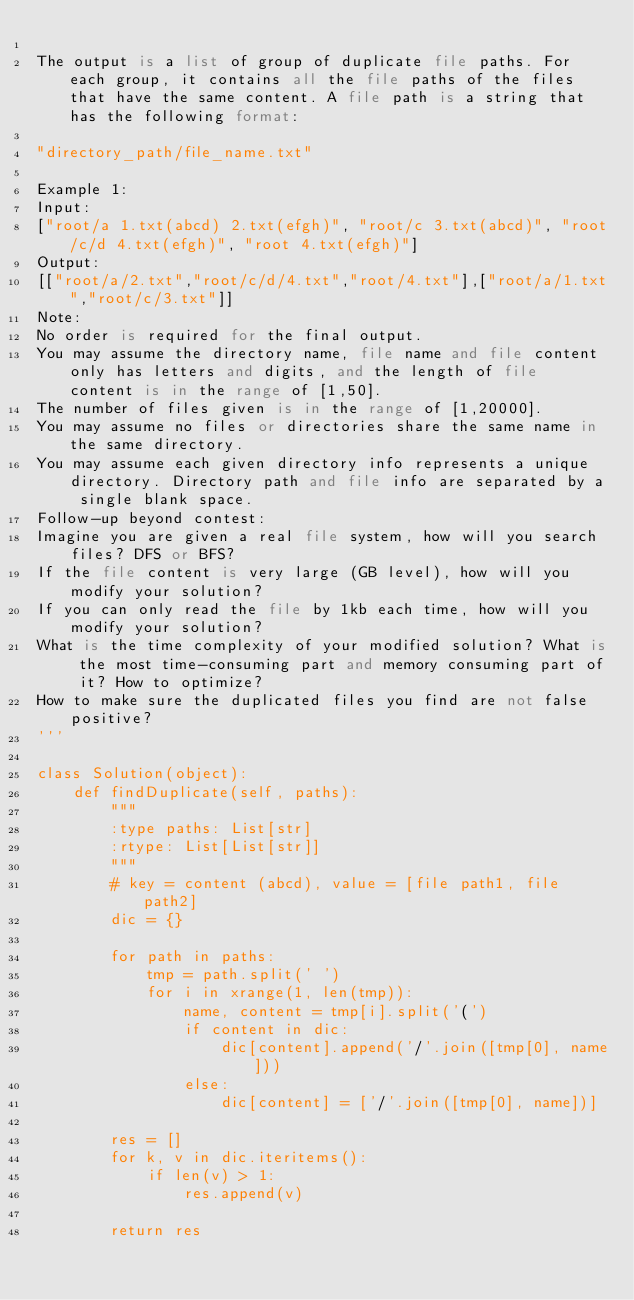<code> <loc_0><loc_0><loc_500><loc_500><_Python_>
The output is a list of group of duplicate file paths. For each group, it contains all the file paths of the files that have the same content. A file path is a string that has the following format:

"directory_path/file_name.txt"

Example 1:
Input:
["root/a 1.txt(abcd) 2.txt(efgh)", "root/c 3.txt(abcd)", "root/c/d 4.txt(efgh)", "root 4.txt(efgh)"]
Output:  
[["root/a/2.txt","root/c/d/4.txt","root/4.txt"],["root/a/1.txt","root/c/3.txt"]]
Note:
No order is required for the final output.
You may assume the directory name, file name and file content only has letters and digits, and the length of file content is in the range of [1,50].
The number of files given is in the range of [1,20000].
You may assume no files or directories share the same name in the same directory.
You may assume each given directory info represents a unique directory. Directory path and file info are separated by a single blank space.
Follow-up beyond contest:
Imagine you are given a real file system, how will you search files? DFS or BFS?
If the file content is very large (GB level), how will you modify your solution?
If you can only read the file by 1kb each time, how will you modify your solution?
What is the time complexity of your modified solution? What is the most time-consuming part and memory consuming part of it? How to optimize?
How to make sure the duplicated files you find are not false positive?
'''

class Solution(object):
    def findDuplicate(self, paths):
        """
        :type paths: List[str]
        :rtype: List[List[str]]
        """
        # key = content (abcd), value = [file path1, file path2]
        dic = {}
        
        for path in paths:
            tmp = path.split(' ')
            for i in xrange(1, len(tmp)):
                name, content = tmp[i].split('(')
                if content in dic:
                    dic[content].append('/'.join([tmp[0], name]))
                else:
                    dic[content] = ['/'.join([tmp[0], name])]
                
        res = []
        for k, v in dic.iteritems():
            if len(v) > 1:
                res.append(v)
            
        return res
        
</code> 